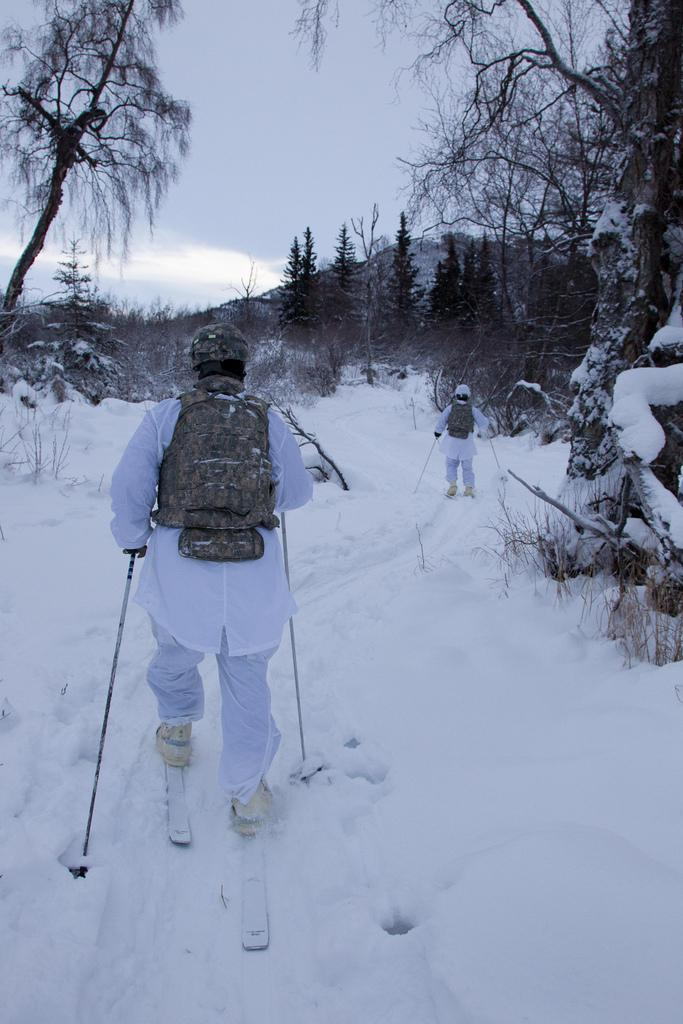Question: what are the two men wearing?
Choices:
A. Jackets.
B. Pants.
C. Boots.
D. Camo helmets.
Answer with the letter. Answer: D Question: who blends to their surroundings?
Choices:
A. The animals.
B. The men.
C. The men's jackets.
D. The men's hats.
Answer with the letter. Answer: B Question: what do the men seem to follow into the woods?
Choices:
A. An animal trail.
B. A bear's foot print.
C. A deer's foot prints.
D. A ski trail.
Answer with the letter. Answer: D Question: where are the men traveling?
Choices:
A. To Paris.
B. To the store.
C. Down the road.
D. Up a mountain.
Answer with the letter. Answer: D Question: what are the men doing?
Choices:
A. Cross country skiing.
B. Skateboarding.
C. Snowboarding.
D. Water skiing.
Answer with the letter. Answer: A Question: why do people do this?
Choices:
A. To have fun.
B. Exercise and hobby.
C. To stay in shape.
D. For their health.
Answer with the letter. Answer: B Question: what are in the men's hands?
Choices:
A. Paper plates.
B. Iced tea.
C. Poles.
D. Hot dogs.
Answer with the letter. Answer: C Question: what is on the men's back?
Choices:
A. Shirts.
B. Backpacks.
C. The sun.
D. Tattoos.
Answer with the letter. Answer: B Question: when is this picture taken?
Choices:
A. At sunrise.
B. At dusk.
C. In the late afternoon.
D. Thanksgiving dinner.
Answer with the letter. Answer: B Question: what is the man on?
Choices:
A. A horse.
B. A bike.
C. A boat.
D. Snow.
Answer with the letter. Answer: D Question: what are the people doing?
Choices:
A. Swimming.
B. Eating.
C. Skiing.
D. Playing volleyball.
Answer with the letter. Answer: C Question: what pokes up through thick snow?
Choices:
A. Signs.
B. Trees.
C. Buildings.
D. Weeds.
Answer with the letter. Answer: D Question: what is in background?
Choices:
A. Evergreen trees.
B. Blue sky.
C. Buildings.
D. The ocean.
Answer with the letter. Answer: A Question: who is wearing white?
Choices:
A. Child in background.
B. Woman on right.
C. Man in center.
D. Man in forefront.
Answer with the letter. Answer: D Question: what blends in with snow?
Choices:
A. Pillows.
B. Cotton balls.
C. White clothing.
D. Sugar.
Answer with the letter. Answer: C Question: what are both skiers wearing?
Choices:
A. Hats.
B. Masks.
C. Googles.
D. Scarves.
Answer with the letter. Answer: A Question: what is in the snow?
Choices:
A. Ski tracks.
B. Dirt.
C. Footsteps.
D. Tire tracks.
Answer with the letter. Answer: A Question: what is hanging in the trees?
Choices:
A. A kite.
B. Snow.
C. A monkey.
D. Lights.
Answer with the letter. Answer: B 